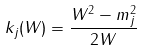Convert formula to latex. <formula><loc_0><loc_0><loc_500><loc_500>k _ { j } ( W ) = \frac { W ^ { 2 } - m _ { j } ^ { 2 } } { 2 W }</formula> 